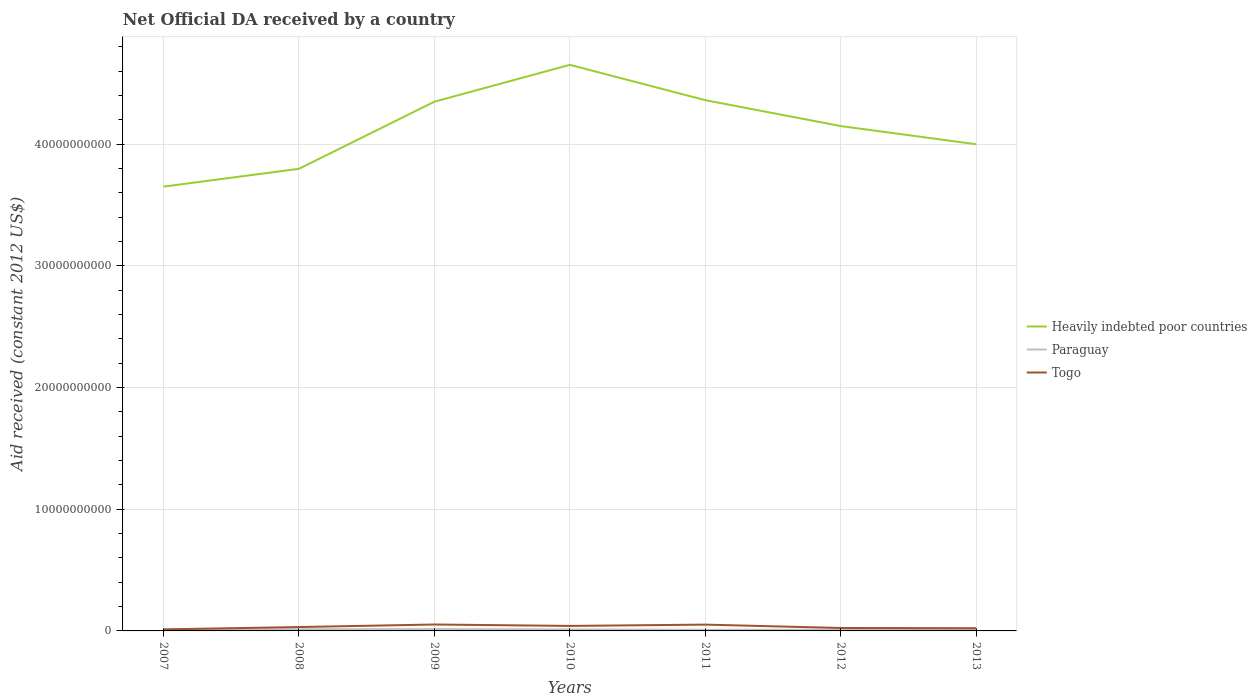Does the line corresponding to Paraguay intersect with the line corresponding to Togo?
Offer a very short reply. No. Is the number of lines equal to the number of legend labels?
Offer a very short reply. Yes. Across all years, what is the maximum net official development assistance aid received in Togo?
Offer a very short reply. 1.26e+08. What is the total net official development assistance aid received in Heavily indebted poor countries in the graph?
Provide a succinct answer. 6.52e+09. What is the difference between the highest and the second highest net official development assistance aid received in Heavily indebted poor countries?
Your answer should be compact. 1.00e+1. What is the difference between the highest and the lowest net official development assistance aid received in Togo?
Provide a succinct answer. 3. How many lines are there?
Your answer should be compact. 3. How many years are there in the graph?
Your response must be concise. 7. Are the values on the major ticks of Y-axis written in scientific E-notation?
Provide a succinct answer. No. Does the graph contain any zero values?
Provide a short and direct response. No. Where does the legend appear in the graph?
Offer a very short reply. Center right. How many legend labels are there?
Your answer should be very brief. 3. How are the legend labels stacked?
Make the answer very short. Vertical. What is the title of the graph?
Provide a short and direct response. Net Official DA received by a country. Does "Belgium" appear as one of the legend labels in the graph?
Your response must be concise. No. What is the label or title of the X-axis?
Your answer should be compact. Years. What is the label or title of the Y-axis?
Ensure brevity in your answer.  Aid received (constant 2012 US$). What is the Aid received (constant 2012 US$) of Heavily indebted poor countries in 2007?
Ensure brevity in your answer.  3.65e+1. What is the Aid received (constant 2012 US$) in Paraguay in 2007?
Provide a short and direct response. 1.21e+08. What is the Aid received (constant 2012 US$) of Togo in 2007?
Offer a terse response. 1.26e+08. What is the Aid received (constant 2012 US$) in Heavily indebted poor countries in 2008?
Your response must be concise. 3.80e+1. What is the Aid received (constant 2012 US$) in Paraguay in 2008?
Offer a terse response. 1.39e+08. What is the Aid received (constant 2012 US$) of Togo in 2008?
Your answer should be very brief. 3.19e+08. What is the Aid received (constant 2012 US$) in Heavily indebted poor countries in 2009?
Your response must be concise. 4.35e+1. What is the Aid received (constant 2012 US$) of Paraguay in 2009?
Keep it short and to the point. 1.50e+08. What is the Aid received (constant 2012 US$) of Togo in 2009?
Make the answer very short. 5.28e+08. What is the Aid received (constant 2012 US$) in Heavily indebted poor countries in 2010?
Keep it short and to the point. 4.65e+1. What is the Aid received (constant 2012 US$) of Paraguay in 2010?
Provide a succinct answer. 1.23e+08. What is the Aid received (constant 2012 US$) in Togo in 2010?
Provide a succinct answer. 4.10e+08. What is the Aid received (constant 2012 US$) in Heavily indebted poor countries in 2011?
Make the answer very short. 4.36e+1. What is the Aid received (constant 2012 US$) of Paraguay in 2011?
Your response must be concise. 9.12e+07. What is the Aid received (constant 2012 US$) in Togo in 2011?
Offer a terse response. 5.18e+08. What is the Aid received (constant 2012 US$) in Heavily indebted poor countries in 2012?
Your answer should be compact. 4.15e+1. What is the Aid received (constant 2012 US$) in Paraguay in 2012?
Provide a succinct answer. 1.04e+08. What is the Aid received (constant 2012 US$) of Togo in 2012?
Offer a very short reply. 2.41e+08. What is the Aid received (constant 2012 US$) in Heavily indebted poor countries in 2013?
Keep it short and to the point. 4.00e+1. What is the Aid received (constant 2012 US$) in Paraguay in 2013?
Provide a short and direct response. 1.25e+08. What is the Aid received (constant 2012 US$) of Togo in 2013?
Your response must be concise. 2.22e+08. Across all years, what is the maximum Aid received (constant 2012 US$) in Heavily indebted poor countries?
Offer a very short reply. 4.65e+1. Across all years, what is the maximum Aid received (constant 2012 US$) in Paraguay?
Offer a terse response. 1.50e+08. Across all years, what is the maximum Aid received (constant 2012 US$) in Togo?
Make the answer very short. 5.28e+08. Across all years, what is the minimum Aid received (constant 2012 US$) of Heavily indebted poor countries?
Give a very brief answer. 3.65e+1. Across all years, what is the minimum Aid received (constant 2012 US$) of Paraguay?
Your answer should be very brief. 9.12e+07. Across all years, what is the minimum Aid received (constant 2012 US$) of Togo?
Your answer should be very brief. 1.26e+08. What is the total Aid received (constant 2012 US$) of Heavily indebted poor countries in the graph?
Your response must be concise. 2.90e+11. What is the total Aid received (constant 2012 US$) of Paraguay in the graph?
Give a very brief answer. 8.53e+08. What is the total Aid received (constant 2012 US$) in Togo in the graph?
Provide a succinct answer. 2.36e+09. What is the difference between the Aid received (constant 2012 US$) in Heavily indebted poor countries in 2007 and that in 2008?
Ensure brevity in your answer.  -1.46e+09. What is the difference between the Aid received (constant 2012 US$) in Paraguay in 2007 and that in 2008?
Provide a succinct answer. -1.80e+07. What is the difference between the Aid received (constant 2012 US$) of Togo in 2007 and that in 2008?
Make the answer very short. -1.93e+08. What is the difference between the Aid received (constant 2012 US$) in Heavily indebted poor countries in 2007 and that in 2009?
Your response must be concise. -6.98e+09. What is the difference between the Aid received (constant 2012 US$) of Paraguay in 2007 and that in 2009?
Your answer should be compact. -2.95e+07. What is the difference between the Aid received (constant 2012 US$) in Togo in 2007 and that in 2009?
Give a very brief answer. -4.02e+08. What is the difference between the Aid received (constant 2012 US$) in Heavily indebted poor countries in 2007 and that in 2010?
Keep it short and to the point. -1.00e+1. What is the difference between the Aid received (constant 2012 US$) in Paraguay in 2007 and that in 2010?
Give a very brief answer. -1.62e+06. What is the difference between the Aid received (constant 2012 US$) in Togo in 2007 and that in 2010?
Your answer should be compact. -2.84e+08. What is the difference between the Aid received (constant 2012 US$) in Heavily indebted poor countries in 2007 and that in 2011?
Provide a succinct answer. -7.10e+09. What is the difference between the Aid received (constant 2012 US$) of Paraguay in 2007 and that in 2011?
Offer a terse response. 2.98e+07. What is the difference between the Aid received (constant 2012 US$) in Togo in 2007 and that in 2011?
Offer a terse response. -3.92e+08. What is the difference between the Aid received (constant 2012 US$) of Heavily indebted poor countries in 2007 and that in 2012?
Offer a terse response. -4.98e+09. What is the difference between the Aid received (constant 2012 US$) of Paraguay in 2007 and that in 2012?
Give a very brief answer. 1.65e+07. What is the difference between the Aid received (constant 2012 US$) in Togo in 2007 and that in 2012?
Your answer should be compact. -1.16e+08. What is the difference between the Aid received (constant 2012 US$) of Heavily indebted poor countries in 2007 and that in 2013?
Make the answer very short. -3.48e+09. What is the difference between the Aid received (constant 2012 US$) in Paraguay in 2007 and that in 2013?
Offer a terse response. -3.61e+06. What is the difference between the Aid received (constant 2012 US$) in Togo in 2007 and that in 2013?
Give a very brief answer. -9.61e+07. What is the difference between the Aid received (constant 2012 US$) in Heavily indebted poor countries in 2008 and that in 2009?
Your answer should be very brief. -5.51e+09. What is the difference between the Aid received (constant 2012 US$) of Paraguay in 2008 and that in 2009?
Make the answer very short. -1.15e+07. What is the difference between the Aid received (constant 2012 US$) of Togo in 2008 and that in 2009?
Your response must be concise. -2.09e+08. What is the difference between the Aid received (constant 2012 US$) of Heavily indebted poor countries in 2008 and that in 2010?
Provide a short and direct response. -8.54e+09. What is the difference between the Aid received (constant 2012 US$) in Paraguay in 2008 and that in 2010?
Your answer should be very brief. 1.64e+07. What is the difference between the Aid received (constant 2012 US$) of Togo in 2008 and that in 2010?
Provide a short and direct response. -9.14e+07. What is the difference between the Aid received (constant 2012 US$) in Heavily indebted poor countries in 2008 and that in 2011?
Make the answer very short. -5.64e+09. What is the difference between the Aid received (constant 2012 US$) of Paraguay in 2008 and that in 2011?
Your answer should be compact. 4.78e+07. What is the difference between the Aid received (constant 2012 US$) of Togo in 2008 and that in 2011?
Your answer should be compact. -1.99e+08. What is the difference between the Aid received (constant 2012 US$) of Heavily indebted poor countries in 2008 and that in 2012?
Keep it short and to the point. -3.51e+09. What is the difference between the Aid received (constant 2012 US$) in Paraguay in 2008 and that in 2012?
Your answer should be compact. 3.45e+07. What is the difference between the Aid received (constant 2012 US$) in Togo in 2008 and that in 2012?
Keep it short and to the point. 7.72e+07. What is the difference between the Aid received (constant 2012 US$) of Heavily indebted poor countries in 2008 and that in 2013?
Keep it short and to the point. -2.02e+09. What is the difference between the Aid received (constant 2012 US$) in Paraguay in 2008 and that in 2013?
Provide a short and direct response. 1.44e+07. What is the difference between the Aid received (constant 2012 US$) of Togo in 2008 and that in 2013?
Your answer should be very brief. 9.67e+07. What is the difference between the Aid received (constant 2012 US$) of Heavily indebted poor countries in 2009 and that in 2010?
Give a very brief answer. -3.03e+09. What is the difference between the Aid received (constant 2012 US$) of Paraguay in 2009 and that in 2010?
Provide a short and direct response. 2.79e+07. What is the difference between the Aid received (constant 2012 US$) of Togo in 2009 and that in 2010?
Provide a short and direct response. 1.18e+08. What is the difference between the Aid received (constant 2012 US$) of Heavily indebted poor countries in 2009 and that in 2011?
Provide a short and direct response. -1.26e+08. What is the difference between the Aid received (constant 2012 US$) of Paraguay in 2009 and that in 2011?
Give a very brief answer. 5.93e+07. What is the difference between the Aid received (constant 2012 US$) in Togo in 2009 and that in 2011?
Make the answer very short. 1.01e+07. What is the difference between the Aid received (constant 2012 US$) of Heavily indebted poor countries in 2009 and that in 2012?
Offer a terse response. 2.00e+09. What is the difference between the Aid received (constant 2012 US$) of Paraguay in 2009 and that in 2012?
Provide a succinct answer. 4.60e+07. What is the difference between the Aid received (constant 2012 US$) of Togo in 2009 and that in 2012?
Provide a short and direct response. 2.87e+08. What is the difference between the Aid received (constant 2012 US$) in Heavily indebted poor countries in 2009 and that in 2013?
Give a very brief answer. 3.50e+09. What is the difference between the Aid received (constant 2012 US$) in Paraguay in 2009 and that in 2013?
Your response must be concise. 2.59e+07. What is the difference between the Aid received (constant 2012 US$) in Togo in 2009 and that in 2013?
Offer a terse response. 3.06e+08. What is the difference between the Aid received (constant 2012 US$) of Heavily indebted poor countries in 2010 and that in 2011?
Your answer should be compact. 2.90e+09. What is the difference between the Aid received (constant 2012 US$) of Paraguay in 2010 and that in 2011?
Your answer should be very brief. 3.14e+07. What is the difference between the Aid received (constant 2012 US$) of Togo in 2010 and that in 2011?
Keep it short and to the point. -1.08e+08. What is the difference between the Aid received (constant 2012 US$) in Heavily indebted poor countries in 2010 and that in 2012?
Provide a succinct answer. 5.03e+09. What is the difference between the Aid received (constant 2012 US$) in Paraguay in 2010 and that in 2012?
Ensure brevity in your answer.  1.82e+07. What is the difference between the Aid received (constant 2012 US$) of Togo in 2010 and that in 2012?
Offer a very short reply. 1.69e+08. What is the difference between the Aid received (constant 2012 US$) of Heavily indebted poor countries in 2010 and that in 2013?
Keep it short and to the point. 6.52e+09. What is the difference between the Aid received (constant 2012 US$) in Paraguay in 2010 and that in 2013?
Ensure brevity in your answer.  -1.99e+06. What is the difference between the Aid received (constant 2012 US$) in Togo in 2010 and that in 2013?
Ensure brevity in your answer.  1.88e+08. What is the difference between the Aid received (constant 2012 US$) in Heavily indebted poor countries in 2011 and that in 2012?
Give a very brief answer. 2.13e+09. What is the difference between the Aid received (constant 2012 US$) in Paraguay in 2011 and that in 2012?
Provide a succinct answer. -1.32e+07. What is the difference between the Aid received (constant 2012 US$) of Togo in 2011 and that in 2012?
Your response must be concise. 2.76e+08. What is the difference between the Aid received (constant 2012 US$) in Heavily indebted poor countries in 2011 and that in 2013?
Make the answer very short. 3.62e+09. What is the difference between the Aid received (constant 2012 US$) of Paraguay in 2011 and that in 2013?
Offer a terse response. -3.34e+07. What is the difference between the Aid received (constant 2012 US$) in Togo in 2011 and that in 2013?
Provide a short and direct response. 2.96e+08. What is the difference between the Aid received (constant 2012 US$) of Heavily indebted poor countries in 2012 and that in 2013?
Give a very brief answer. 1.49e+09. What is the difference between the Aid received (constant 2012 US$) in Paraguay in 2012 and that in 2013?
Provide a succinct answer. -2.01e+07. What is the difference between the Aid received (constant 2012 US$) in Togo in 2012 and that in 2013?
Provide a short and direct response. 1.94e+07. What is the difference between the Aid received (constant 2012 US$) of Heavily indebted poor countries in 2007 and the Aid received (constant 2012 US$) of Paraguay in 2008?
Make the answer very short. 3.64e+1. What is the difference between the Aid received (constant 2012 US$) in Heavily indebted poor countries in 2007 and the Aid received (constant 2012 US$) in Togo in 2008?
Make the answer very short. 3.62e+1. What is the difference between the Aid received (constant 2012 US$) in Paraguay in 2007 and the Aid received (constant 2012 US$) in Togo in 2008?
Your answer should be compact. -1.98e+08. What is the difference between the Aid received (constant 2012 US$) in Heavily indebted poor countries in 2007 and the Aid received (constant 2012 US$) in Paraguay in 2009?
Offer a very short reply. 3.64e+1. What is the difference between the Aid received (constant 2012 US$) in Heavily indebted poor countries in 2007 and the Aid received (constant 2012 US$) in Togo in 2009?
Your response must be concise. 3.60e+1. What is the difference between the Aid received (constant 2012 US$) in Paraguay in 2007 and the Aid received (constant 2012 US$) in Togo in 2009?
Your answer should be compact. -4.07e+08. What is the difference between the Aid received (constant 2012 US$) in Heavily indebted poor countries in 2007 and the Aid received (constant 2012 US$) in Paraguay in 2010?
Provide a succinct answer. 3.64e+1. What is the difference between the Aid received (constant 2012 US$) in Heavily indebted poor countries in 2007 and the Aid received (constant 2012 US$) in Togo in 2010?
Your answer should be compact. 3.61e+1. What is the difference between the Aid received (constant 2012 US$) in Paraguay in 2007 and the Aid received (constant 2012 US$) in Togo in 2010?
Your answer should be very brief. -2.89e+08. What is the difference between the Aid received (constant 2012 US$) of Heavily indebted poor countries in 2007 and the Aid received (constant 2012 US$) of Paraguay in 2011?
Ensure brevity in your answer.  3.64e+1. What is the difference between the Aid received (constant 2012 US$) in Heavily indebted poor countries in 2007 and the Aid received (constant 2012 US$) in Togo in 2011?
Your response must be concise. 3.60e+1. What is the difference between the Aid received (constant 2012 US$) of Paraguay in 2007 and the Aid received (constant 2012 US$) of Togo in 2011?
Offer a terse response. -3.97e+08. What is the difference between the Aid received (constant 2012 US$) in Heavily indebted poor countries in 2007 and the Aid received (constant 2012 US$) in Paraguay in 2012?
Your answer should be very brief. 3.64e+1. What is the difference between the Aid received (constant 2012 US$) of Heavily indebted poor countries in 2007 and the Aid received (constant 2012 US$) of Togo in 2012?
Keep it short and to the point. 3.63e+1. What is the difference between the Aid received (constant 2012 US$) of Paraguay in 2007 and the Aid received (constant 2012 US$) of Togo in 2012?
Ensure brevity in your answer.  -1.21e+08. What is the difference between the Aid received (constant 2012 US$) of Heavily indebted poor countries in 2007 and the Aid received (constant 2012 US$) of Paraguay in 2013?
Provide a succinct answer. 3.64e+1. What is the difference between the Aid received (constant 2012 US$) of Heavily indebted poor countries in 2007 and the Aid received (constant 2012 US$) of Togo in 2013?
Your answer should be very brief. 3.63e+1. What is the difference between the Aid received (constant 2012 US$) in Paraguay in 2007 and the Aid received (constant 2012 US$) in Togo in 2013?
Give a very brief answer. -1.01e+08. What is the difference between the Aid received (constant 2012 US$) in Heavily indebted poor countries in 2008 and the Aid received (constant 2012 US$) in Paraguay in 2009?
Provide a short and direct response. 3.78e+1. What is the difference between the Aid received (constant 2012 US$) in Heavily indebted poor countries in 2008 and the Aid received (constant 2012 US$) in Togo in 2009?
Your answer should be very brief. 3.74e+1. What is the difference between the Aid received (constant 2012 US$) of Paraguay in 2008 and the Aid received (constant 2012 US$) of Togo in 2009?
Your answer should be compact. -3.89e+08. What is the difference between the Aid received (constant 2012 US$) of Heavily indebted poor countries in 2008 and the Aid received (constant 2012 US$) of Paraguay in 2010?
Your answer should be compact. 3.78e+1. What is the difference between the Aid received (constant 2012 US$) of Heavily indebted poor countries in 2008 and the Aid received (constant 2012 US$) of Togo in 2010?
Your answer should be compact. 3.76e+1. What is the difference between the Aid received (constant 2012 US$) of Paraguay in 2008 and the Aid received (constant 2012 US$) of Togo in 2010?
Keep it short and to the point. -2.71e+08. What is the difference between the Aid received (constant 2012 US$) in Heavily indebted poor countries in 2008 and the Aid received (constant 2012 US$) in Paraguay in 2011?
Provide a short and direct response. 3.79e+1. What is the difference between the Aid received (constant 2012 US$) in Heavily indebted poor countries in 2008 and the Aid received (constant 2012 US$) in Togo in 2011?
Your answer should be very brief. 3.74e+1. What is the difference between the Aid received (constant 2012 US$) of Paraguay in 2008 and the Aid received (constant 2012 US$) of Togo in 2011?
Keep it short and to the point. -3.79e+08. What is the difference between the Aid received (constant 2012 US$) of Heavily indebted poor countries in 2008 and the Aid received (constant 2012 US$) of Paraguay in 2012?
Provide a short and direct response. 3.79e+1. What is the difference between the Aid received (constant 2012 US$) of Heavily indebted poor countries in 2008 and the Aid received (constant 2012 US$) of Togo in 2012?
Make the answer very short. 3.77e+1. What is the difference between the Aid received (constant 2012 US$) in Paraguay in 2008 and the Aid received (constant 2012 US$) in Togo in 2012?
Give a very brief answer. -1.03e+08. What is the difference between the Aid received (constant 2012 US$) of Heavily indebted poor countries in 2008 and the Aid received (constant 2012 US$) of Paraguay in 2013?
Your answer should be compact. 3.78e+1. What is the difference between the Aid received (constant 2012 US$) in Heavily indebted poor countries in 2008 and the Aid received (constant 2012 US$) in Togo in 2013?
Keep it short and to the point. 3.77e+1. What is the difference between the Aid received (constant 2012 US$) of Paraguay in 2008 and the Aid received (constant 2012 US$) of Togo in 2013?
Offer a terse response. -8.31e+07. What is the difference between the Aid received (constant 2012 US$) of Heavily indebted poor countries in 2009 and the Aid received (constant 2012 US$) of Paraguay in 2010?
Provide a succinct answer. 4.34e+1. What is the difference between the Aid received (constant 2012 US$) of Heavily indebted poor countries in 2009 and the Aid received (constant 2012 US$) of Togo in 2010?
Make the answer very short. 4.31e+1. What is the difference between the Aid received (constant 2012 US$) of Paraguay in 2009 and the Aid received (constant 2012 US$) of Togo in 2010?
Your response must be concise. -2.60e+08. What is the difference between the Aid received (constant 2012 US$) in Heavily indebted poor countries in 2009 and the Aid received (constant 2012 US$) in Paraguay in 2011?
Keep it short and to the point. 4.34e+1. What is the difference between the Aid received (constant 2012 US$) of Heavily indebted poor countries in 2009 and the Aid received (constant 2012 US$) of Togo in 2011?
Make the answer very short. 4.30e+1. What is the difference between the Aid received (constant 2012 US$) of Paraguay in 2009 and the Aid received (constant 2012 US$) of Togo in 2011?
Offer a terse response. -3.67e+08. What is the difference between the Aid received (constant 2012 US$) in Heavily indebted poor countries in 2009 and the Aid received (constant 2012 US$) in Paraguay in 2012?
Keep it short and to the point. 4.34e+1. What is the difference between the Aid received (constant 2012 US$) in Heavily indebted poor countries in 2009 and the Aid received (constant 2012 US$) in Togo in 2012?
Your answer should be compact. 4.32e+1. What is the difference between the Aid received (constant 2012 US$) of Paraguay in 2009 and the Aid received (constant 2012 US$) of Togo in 2012?
Your answer should be compact. -9.10e+07. What is the difference between the Aid received (constant 2012 US$) in Heavily indebted poor countries in 2009 and the Aid received (constant 2012 US$) in Paraguay in 2013?
Ensure brevity in your answer.  4.34e+1. What is the difference between the Aid received (constant 2012 US$) of Heavily indebted poor countries in 2009 and the Aid received (constant 2012 US$) of Togo in 2013?
Give a very brief answer. 4.33e+1. What is the difference between the Aid received (constant 2012 US$) of Paraguay in 2009 and the Aid received (constant 2012 US$) of Togo in 2013?
Provide a short and direct response. -7.16e+07. What is the difference between the Aid received (constant 2012 US$) of Heavily indebted poor countries in 2010 and the Aid received (constant 2012 US$) of Paraguay in 2011?
Give a very brief answer. 4.64e+1. What is the difference between the Aid received (constant 2012 US$) of Heavily indebted poor countries in 2010 and the Aid received (constant 2012 US$) of Togo in 2011?
Make the answer very short. 4.60e+1. What is the difference between the Aid received (constant 2012 US$) of Paraguay in 2010 and the Aid received (constant 2012 US$) of Togo in 2011?
Provide a succinct answer. -3.95e+08. What is the difference between the Aid received (constant 2012 US$) in Heavily indebted poor countries in 2010 and the Aid received (constant 2012 US$) in Paraguay in 2012?
Your response must be concise. 4.64e+1. What is the difference between the Aid received (constant 2012 US$) in Heavily indebted poor countries in 2010 and the Aid received (constant 2012 US$) in Togo in 2012?
Offer a very short reply. 4.63e+1. What is the difference between the Aid received (constant 2012 US$) of Paraguay in 2010 and the Aid received (constant 2012 US$) of Togo in 2012?
Your response must be concise. -1.19e+08. What is the difference between the Aid received (constant 2012 US$) of Heavily indebted poor countries in 2010 and the Aid received (constant 2012 US$) of Paraguay in 2013?
Give a very brief answer. 4.64e+1. What is the difference between the Aid received (constant 2012 US$) of Heavily indebted poor countries in 2010 and the Aid received (constant 2012 US$) of Togo in 2013?
Ensure brevity in your answer.  4.63e+1. What is the difference between the Aid received (constant 2012 US$) in Paraguay in 2010 and the Aid received (constant 2012 US$) in Togo in 2013?
Your response must be concise. -9.95e+07. What is the difference between the Aid received (constant 2012 US$) in Heavily indebted poor countries in 2011 and the Aid received (constant 2012 US$) in Paraguay in 2012?
Keep it short and to the point. 4.35e+1. What is the difference between the Aid received (constant 2012 US$) of Heavily indebted poor countries in 2011 and the Aid received (constant 2012 US$) of Togo in 2012?
Your answer should be very brief. 4.34e+1. What is the difference between the Aid received (constant 2012 US$) of Paraguay in 2011 and the Aid received (constant 2012 US$) of Togo in 2012?
Offer a very short reply. -1.50e+08. What is the difference between the Aid received (constant 2012 US$) in Heavily indebted poor countries in 2011 and the Aid received (constant 2012 US$) in Paraguay in 2013?
Offer a very short reply. 4.35e+1. What is the difference between the Aid received (constant 2012 US$) in Heavily indebted poor countries in 2011 and the Aid received (constant 2012 US$) in Togo in 2013?
Make the answer very short. 4.34e+1. What is the difference between the Aid received (constant 2012 US$) in Paraguay in 2011 and the Aid received (constant 2012 US$) in Togo in 2013?
Give a very brief answer. -1.31e+08. What is the difference between the Aid received (constant 2012 US$) in Heavily indebted poor countries in 2012 and the Aid received (constant 2012 US$) in Paraguay in 2013?
Your response must be concise. 4.14e+1. What is the difference between the Aid received (constant 2012 US$) in Heavily indebted poor countries in 2012 and the Aid received (constant 2012 US$) in Togo in 2013?
Offer a terse response. 4.13e+1. What is the difference between the Aid received (constant 2012 US$) of Paraguay in 2012 and the Aid received (constant 2012 US$) of Togo in 2013?
Keep it short and to the point. -1.18e+08. What is the average Aid received (constant 2012 US$) of Heavily indebted poor countries per year?
Give a very brief answer. 4.14e+1. What is the average Aid received (constant 2012 US$) of Paraguay per year?
Your answer should be compact. 1.22e+08. What is the average Aid received (constant 2012 US$) in Togo per year?
Ensure brevity in your answer.  3.38e+08. In the year 2007, what is the difference between the Aid received (constant 2012 US$) in Heavily indebted poor countries and Aid received (constant 2012 US$) in Paraguay?
Your response must be concise. 3.64e+1. In the year 2007, what is the difference between the Aid received (constant 2012 US$) of Heavily indebted poor countries and Aid received (constant 2012 US$) of Togo?
Provide a succinct answer. 3.64e+1. In the year 2007, what is the difference between the Aid received (constant 2012 US$) of Paraguay and Aid received (constant 2012 US$) of Togo?
Ensure brevity in your answer.  -5.00e+06. In the year 2008, what is the difference between the Aid received (constant 2012 US$) of Heavily indebted poor countries and Aid received (constant 2012 US$) of Paraguay?
Provide a short and direct response. 3.78e+1. In the year 2008, what is the difference between the Aid received (constant 2012 US$) in Heavily indebted poor countries and Aid received (constant 2012 US$) in Togo?
Provide a succinct answer. 3.76e+1. In the year 2008, what is the difference between the Aid received (constant 2012 US$) in Paraguay and Aid received (constant 2012 US$) in Togo?
Offer a very short reply. -1.80e+08. In the year 2009, what is the difference between the Aid received (constant 2012 US$) of Heavily indebted poor countries and Aid received (constant 2012 US$) of Paraguay?
Provide a succinct answer. 4.33e+1. In the year 2009, what is the difference between the Aid received (constant 2012 US$) of Heavily indebted poor countries and Aid received (constant 2012 US$) of Togo?
Make the answer very short. 4.30e+1. In the year 2009, what is the difference between the Aid received (constant 2012 US$) of Paraguay and Aid received (constant 2012 US$) of Togo?
Provide a short and direct response. -3.78e+08. In the year 2010, what is the difference between the Aid received (constant 2012 US$) in Heavily indebted poor countries and Aid received (constant 2012 US$) in Paraguay?
Your response must be concise. 4.64e+1. In the year 2010, what is the difference between the Aid received (constant 2012 US$) in Heavily indebted poor countries and Aid received (constant 2012 US$) in Togo?
Your response must be concise. 4.61e+1. In the year 2010, what is the difference between the Aid received (constant 2012 US$) in Paraguay and Aid received (constant 2012 US$) in Togo?
Provide a short and direct response. -2.88e+08. In the year 2011, what is the difference between the Aid received (constant 2012 US$) in Heavily indebted poor countries and Aid received (constant 2012 US$) in Paraguay?
Offer a terse response. 4.35e+1. In the year 2011, what is the difference between the Aid received (constant 2012 US$) of Heavily indebted poor countries and Aid received (constant 2012 US$) of Togo?
Provide a short and direct response. 4.31e+1. In the year 2011, what is the difference between the Aid received (constant 2012 US$) in Paraguay and Aid received (constant 2012 US$) in Togo?
Make the answer very short. -4.27e+08. In the year 2012, what is the difference between the Aid received (constant 2012 US$) of Heavily indebted poor countries and Aid received (constant 2012 US$) of Paraguay?
Give a very brief answer. 4.14e+1. In the year 2012, what is the difference between the Aid received (constant 2012 US$) in Heavily indebted poor countries and Aid received (constant 2012 US$) in Togo?
Make the answer very short. 4.12e+1. In the year 2012, what is the difference between the Aid received (constant 2012 US$) in Paraguay and Aid received (constant 2012 US$) in Togo?
Offer a very short reply. -1.37e+08. In the year 2013, what is the difference between the Aid received (constant 2012 US$) in Heavily indebted poor countries and Aid received (constant 2012 US$) in Paraguay?
Your response must be concise. 3.99e+1. In the year 2013, what is the difference between the Aid received (constant 2012 US$) in Heavily indebted poor countries and Aid received (constant 2012 US$) in Togo?
Your answer should be very brief. 3.98e+1. In the year 2013, what is the difference between the Aid received (constant 2012 US$) of Paraguay and Aid received (constant 2012 US$) of Togo?
Your answer should be compact. -9.75e+07. What is the ratio of the Aid received (constant 2012 US$) in Heavily indebted poor countries in 2007 to that in 2008?
Your response must be concise. 0.96. What is the ratio of the Aid received (constant 2012 US$) in Paraguay in 2007 to that in 2008?
Give a very brief answer. 0.87. What is the ratio of the Aid received (constant 2012 US$) in Togo in 2007 to that in 2008?
Offer a very short reply. 0.4. What is the ratio of the Aid received (constant 2012 US$) in Heavily indebted poor countries in 2007 to that in 2009?
Ensure brevity in your answer.  0.84. What is the ratio of the Aid received (constant 2012 US$) in Paraguay in 2007 to that in 2009?
Make the answer very short. 0.8. What is the ratio of the Aid received (constant 2012 US$) in Togo in 2007 to that in 2009?
Ensure brevity in your answer.  0.24. What is the ratio of the Aid received (constant 2012 US$) of Heavily indebted poor countries in 2007 to that in 2010?
Your answer should be compact. 0.78. What is the ratio of the Aid received (constant 2012 US$) of Togo in 2007 to that in 2010?
Provide a short and direct response. 0.31. What is the ratio of the Aid received (constant 2012 US$) in Heavily indebted poor countries in 2007 to that in 2011?
Ensure brevity in your answer.  0.84. What is the ratio of the Aid received (constant 2012 US$) in Paraguay in 2007 to that in 2011?
Your answer should be very brief. 1.33. What is the ratio of the Aid received (constant 2012 US$) in Togo in 2007 to that in 2011?
Keep it short and to the point. 0.24. What is the ratio of the Aid received (constant 2012 US$) of Paraguay in 2007 to that in 2012?
Make the answer very short. 1.16. What is the ratio of the Aid received (constant 2012 US$) in Togo in 2007 to that in 2012?
Offer a terse response. 0.52. What is the ratio of the Aid received (constant 2012 US$) of Heavily indebted poor countries in 2007 to that in 2013?
Make the answer very short. 0.91. What is the ratio of the Aid received (constant 2012 US$) of Paraguay in 2007 to that in 2013?
Offer a very short reply. 0.97. What is the ratio of the Aid received (constant 2012 US$) in Togo in 2007 to that in 2013?
Provide a short and direct response. 0.57. What is the ratio of the Aid received (constant 2012 US$) of Heavily indebted poor countries in 2008 to that in 2009?
Offer a very short reply. 0.87. What is the ratio of the Aid received (constant 2012 US$) in Paraguay in 2008 to that in 2009?
Your answer should be very brief. 0.92. What is the ratio of the Aid received (constant 2012 US$) in Togo in 2008 to that in 2009?
Your answer should be compact. 0.6. What is the ratio of the Aid received (constant 2012 US$) of Heavily indebted poor countries in 2008 to that in 2010?
Your answer should be very brief. 0.82. What is the ratio of the Aid received (constant 2012 US$) of Paraguay in 2008 to that in 2010?
Your answer should be very brief. 1.13. What is the ratio of the Aid received (constant 2012 US$) of Togo in 2008 to that in 2010?
Ensure brevity in your answer.  0.78. What is the ratio of the Aid received (constant 2012 US$) in Heavily indebted poor countries in 2008 to that in 2011?
Ensure brevity in your answer.  0.87. What is the ratio of the Aid received (constant 2012 US$) in Paraguay in 2008 to that in 2011?
Offer a very short reply. 1.52. What is the ratio of the Aid received (constant 2012 US$) of Togo in 2008 to that in 2011?
Make the answer very short. 0.62. What is the ratio of the Aid received (constant 2012 US$) in Heavily indebted poor countries in 2008 to that in 2012?
Your answer should be compact. 0.92. What is the ratio of the Aid received (constant 2012 US$) of Paraguay in 2008 to that in 2012?
Your answer should be compact. 1.33. What is the ratio of the Aid received (constant 2012 US$) of Togo in 2008 to that in 2012?
Your answer should be compact. 1.32. What is the ratio of the Aid received (constant 2012 US$) in Heavily indebted poor countries in 2008 to that in 2013?
Keep it short and to the point. 0.95. What is the ratio of the Aid received (constant 2012 US$) of Paraguay in 2008 to that in 2013?
Provide a succinct answer. 1.12. What is the ratio of the Aid received (constant 2012 US$) in Togo in 2008 to that in 2013?
Offer a very short reply. 1.44. What is the ratio of the Aid received (constant 2012 US$) of Heavily indebted poor countries in 2009 to that in 2010?
Your answer should be compact. 0.93. What is the ratio of the Aid received (constant 2012 US$) in Paraguay in 2009 to that in 2010?
Your answer should be compact. 1.23. What is the ratio of the Aid received (constant 2012 US$) in Togo in 2009 to that in 2010?
Provide a succinct answer. 1.29. What is the ratio of the Aid received (constant 2012 US$) in Paraguay in 2009 to that in 2011?
Provide a succinct answer. 1.65. What is the ratio of the Aid received (constant 2012 US$) of Togo in 2009 to that in 2011?
Offer a terse response. 1.02. What is the ratio of the Aid received (constant 2012 US$) of Heavily indebted poor countries in 2009 to that in 2012?
Provide a short and direct response. 1.05. What is the ratio of the Aid received (constant 2012 US$) of Paraguay in 2009 to that in 2012?
Your response must be concise. 1.44. What is the ratio of the Aid received (constant 2012 US$) in Togo in 2009 to that in 2012?
Your answer should be very brief. 2.19. What is the ratio of the Aid received (constant 2012 US$) of Heavily indebted poor countries in 2009 to that in 2013?
Offer a very short reply. 1.09. What is the ratio of the Aid received (constant 2012 US$) in Paraguay in 2009 to that in 2013?
Give a very brief answer. 1.21. What is the ratio of the Aid received (constant 2012 US$) of Togo in 2009 to that in 2013?
Make the answer very short. 2.38. What is the ratio of the Aid received (constant 2012 US$) in Heavily indebted poor countries in 2010 to that in 2011?
Make the answer very short. 1.07. What is the ratio of the Aid received (constant 2012 US$) in Paraguay in 2010 to that in 2011?
Give a very brief answer. 1.34. What is the ratio of the Aid received (constant 2012 US$) of Togo in 2010 to that in 2011?
Your answer should be very brief. 0.79. What is the ratio of the Aid received (constant 2012 US$) of Heavily indebted poor countries in 2010 to that in 2012?
Your answer should be compact. 1.12. What is the ratio of the Aid received (constant 2012 US$) in Paraguay in 2010 to that in 2012?
Your answer should be compact. 1.17. What is the ratio of the Aid received (constant 2012 US$) in Togo in 2010 to that in 2012?
Provide a short and direct response. 1.7. What is the ratio of the Aid received (constant 2012 US$) of Heavily indebted poor countries in 2010 to that in 2013?
Offer a terse response. 1.16. What is the ratio of the Aid received (constant 2012 US$) in Paraguay in 2010 to that in 2013?
Keep it short and to the point. 0.98. What is the ratio of the Aid received (constant 2012 US$) of Togo in 2010 to that in 2013?
Offer a terse response. 1.85. What is the ratio of the Aid received (constant 2012 US$) in Heavily indebted poor countries in 2011 to that in 2012?
Offer a very short reply. 1.05. What is the ratio of the Aid received (constant 2012 US$) in Paraguay in 2011 to that in 2012?
Offer a terse response. 0.87. What is the ratio of the Aid received (constant 2012 US$) of Togo in 2011 to that in 2012?
Offer a very short reply. 2.14. What is the ratio of the Aid received (constant 2012 US$) of Heavily indebted poor countries in 2011 to that in 2013?
Provide a succinct answer. 1.09. What is the ratio of the Aid received (constant 2012 US$) of Paraguay in 2011 to that in 2013?
Provide a succinct answer. 0.73. What is the ratio of the Aid received (constant 2012 US$) in Togo in 2011 to that in 2013?
Make the answer very short. 2.33. What is the ratio of the Aid received (constant 2012 US$) of Heavily indebted poor countries in 2012 to that in 2013?
Your answer should be very brief. 1.04. What is the ratio of the Aid received (constant 2012 US$) of Paraguay in 2012 to that in 2013?
Make the answer very short. 0.84. What is the ratio of the Aid received (constant 2012 US$) in Togo in 2012 to that in 2013?
Make the answer very short. 1.09. What is the difference between the highest and the second highest Aid received (constant 2012 US$) of Heavily indebted poor countries?
Provide a short and direct response. 2.90e+09. What is the difference between the highest and the second highest Aid received (constant 2012 US$) of Paraguay?
Your answer should be very brief. 1.15e+07. What is the difference between the highest and the second highest Aid received (constant 2012 US$) in Togo?
Provide a short and direct response. 1.01e+07. What is the difference between the highest and the lowest Aid received (constant 2012 US$) in Heavily indebted poor countries?
Your response must be concise. 1.00e+1. What is the difference between the highest and the lowest Aid received (constant 2012 US$) of Paraguay?
Offer a very short reply. 5.93e+07. What is the difference between the highest and the lowest Aid received (constant 2012 US$) in Togo?
Your response must be concise. 4.02e+08. 